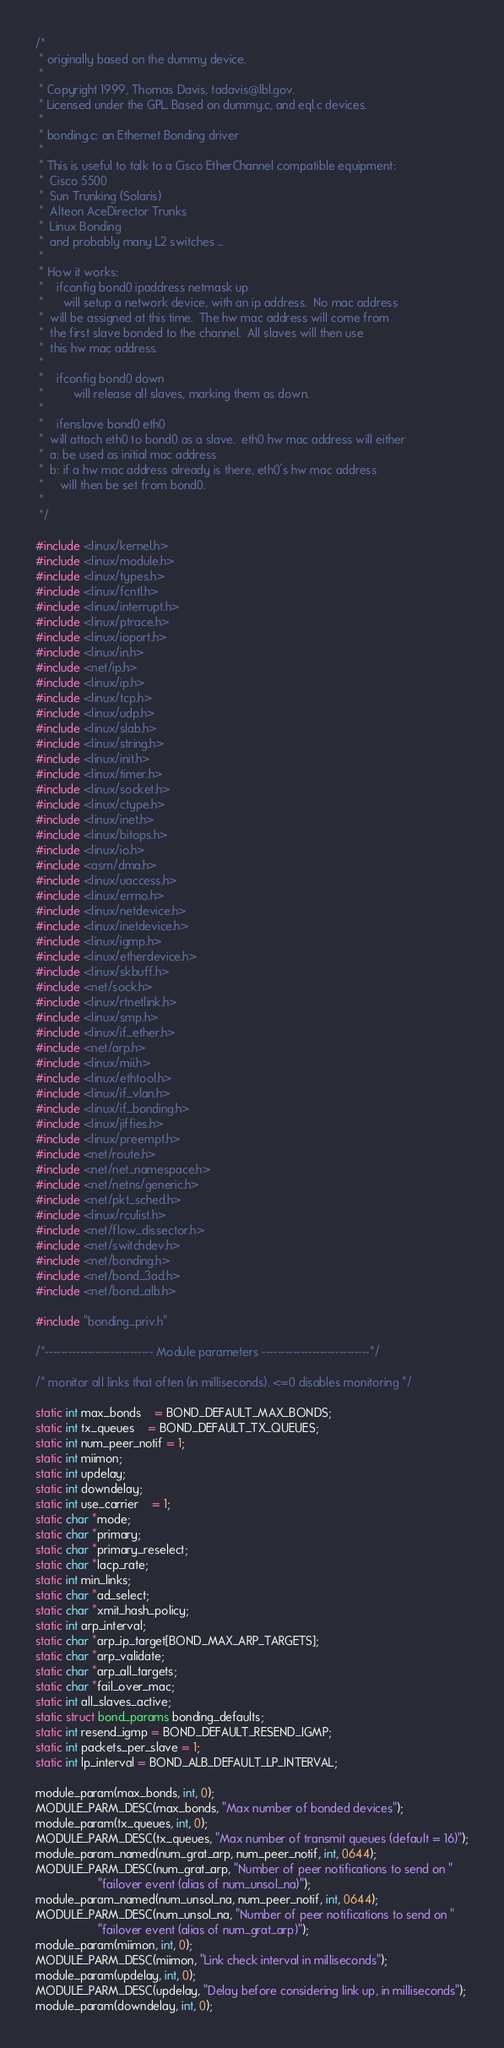Convert code to text. <code><loc_0><loc_0><loc_500><loc_500><_C_>/*
 * originally based on the dummy device.
 *
 * Copyright 1999, Thomas Davis, tadavis@lbl.gov.
 * Licensed under the GPL. Based on dummy.c, and eql.c devices.
 *
 * bonding.c: an Ethernet Bonding driver
 *
 * This is useful to talk to a Cisco EtherChannel compatible equipment:
 *	Cisco 5500
 *	Sun Trunking (Solaris)
 *	Alteon AceDirector Trunks
 *	Linux Bonding
 *	and probably many L2 switches ...
 *
 * How it works:
 *    ifconfig bond0 ipaddress netmask up
 *      will setup a network device, with an ip address.  No mac address
 *	will be assigned at this time.  The hw mac address will come from
 *	the first slave bonded to the channel.  All slaves will then use
 *	this hw mac address.
 *
 *    ifconfig bond0 down
 *         will release all slaves, marking them as down.
 *
 *    ifenslave bond0 eth0
 *	will attach eth0 to bond0 as a slave.  eth0 hw mac address will either
 *	a: be used as initial mac address
 *	b: if a hw mac address already is there, eth0's hw mac address
 *	   will then be set from bond0.
 *
 */

#include <linux/kernel.h>
#include <linux/module.h>
#include <linux/types.h>
#include <linux/fcntl.h>
#include <linux/interrupt.h>
#include <linux/ptrace.h>
#include <linux/ioport.h>
#include <linux/in.h>
#include <net/ip.h>
#include <linux/ip.h>
#include <linux/tcp.h>
#include <linux/udp.h>
#include <linux/slab.h>
#include <linux/string.h>
#include <linux/init.h>
#include <linux/timer.h>
#include <linux/socket.h>
#include <linux/ctype.h>
#include <linux/inet.h>
#include <linux/bitops.h>
#include <linux/io.h>
#include <asm/dma.h>
#include <linux/uaccess.h>
#include <linux/errno.h>
#include <linux/netdevice.h>
#include <linux/inetdevice.h>
#include <linux/igmp.h>
#include <linux/etherdevice.h>
#include <linux/skbuff.h>
#include <net/sock.h>
#include <linux/rtnetlink.h>
#include <linux/smp.h>
#include <linux/if_ether.h>
#include <net/arp.h>
#include <linux/mii.h>
#include <linux/ethtool.h>
#include <linux/if_vlan.h>
#include <linux/if_bonding.h>
#include <linux/jiffies.h>
#include <linux/preempt.h>
#include <net/route.h>
#include <net/net_namespace.h>
#include <net/netns/generic.h>
#include <net/pkt_sched.h>
#include <linux/rculist.h>
#include <net/flow_dissector.h>
#include <net/switchdev.h>
#include <net/bonding.h>
#include <net/bond_3ad.h>
#include <net/bond_alb.h>

#include "bonding_priv.h"

/*---------------------------- Module parameters ----------------------------*/

/* monitor all links that often (in milliseconds). <=0 disables monitoring */

static int max_bonds	= BOND_DEFAULT_MAX_BONDS;
static int tx_queues	= BOND_DEFAULT_TX_QUEUES;
static int num_peer_notif = 1;
static int miimon;
static int updelay;
static int downdelay;
static int use_carrier	= 1;
static char *mode;
static char *primary;
static char *primary_reselect;
static char *lacp_rate;
static int min_links;
static char *ad_select;
static char *xmit_hash_policy;
static int arp_interval;
static char *arp_ip_target[BOND_MAX_ARP_TARGETS];
static char *arp_validate;
static char *arp_all_targets;
static char *fail_over_mac;
static int all_slaves_active;
static struct bond_params bonding_defaults;
static int resend_igmp = BOND_DEFAULT_RESEND_IGMP;
static int packets_per_slave = 1;
static int lp_interval = BOND_ALB_DEFAULT_LP_INTERVAL;

module_param(max_bonds, int, 0);
MODULE_PARM_DESC(max_bonds, "Max number of bonded devices");
module_param(tx_queues, int, 0);
MODULE_PARM_DESC(tx_queues, "Max number of transmit queues (default = 16)");
module_param_named(num_grat_arp, num_peer_notif, int, 0644);
MODULE_PARM_DESC(num_grat_arp, "Number of peer notifications to send on "
			       "failover event (alias of num_unsol_na)");
module_param_named(num_unsol_na, num_peer_notif, int, 0644);
MODULE_PARM_DESC(num_unsol_na, "Number of peer notifications to send on "
			       "failover event (alias of num_grat_arp)");
module_param(miimon, int, 0);
MODULE_PARM_DESC(miimon, "Link check interval in milliseconds");
module_param(updelay, int, 0);
MODULE_PARM_DESC(updelay, "Delay before considering link up, in milliseconds");
module_param(downdelay, int, 0);</code> 